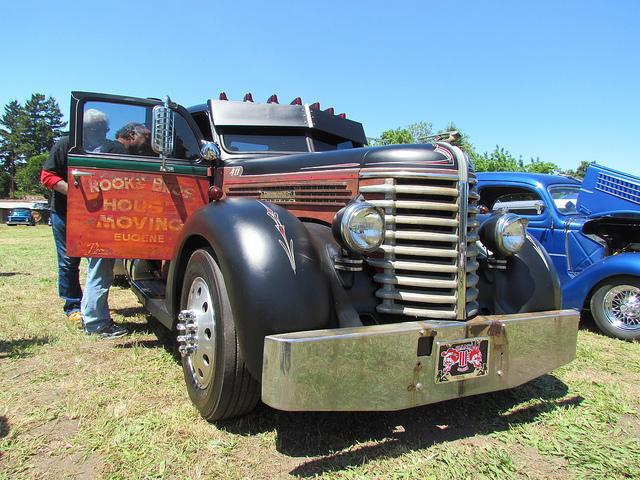These types of vehicles are commonly referred to as what? trucks 